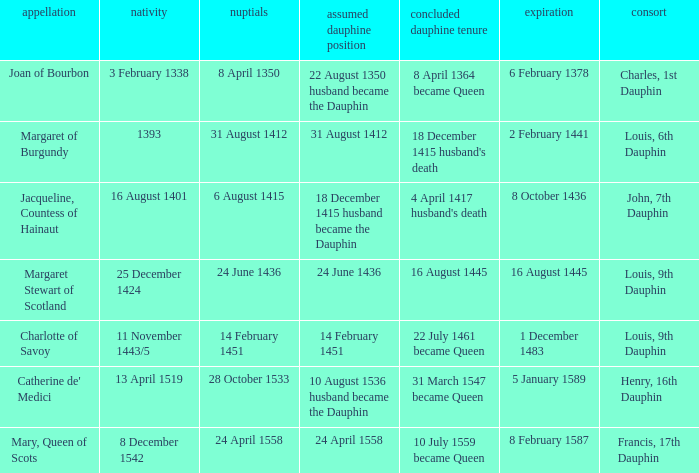When was the death of the person with husband charles, 1st dauphin? 6 February 1378. 